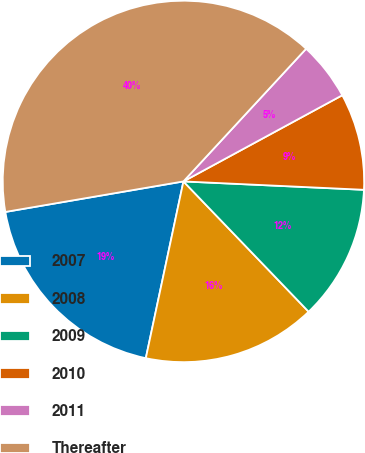<chart> <loc_0><loc_0><loc_500><loc_500><pie_chart><fcel>2007<fcel>2008<fcel>2009<fcel>2010<fcel>2011<fcel>Thereafter<nl><fcel>18.96%<fcel>15.52%<fcel>12.08%<fcel>8.65%<fcel>5.21%<fcel>39.58%<nl></chart> 